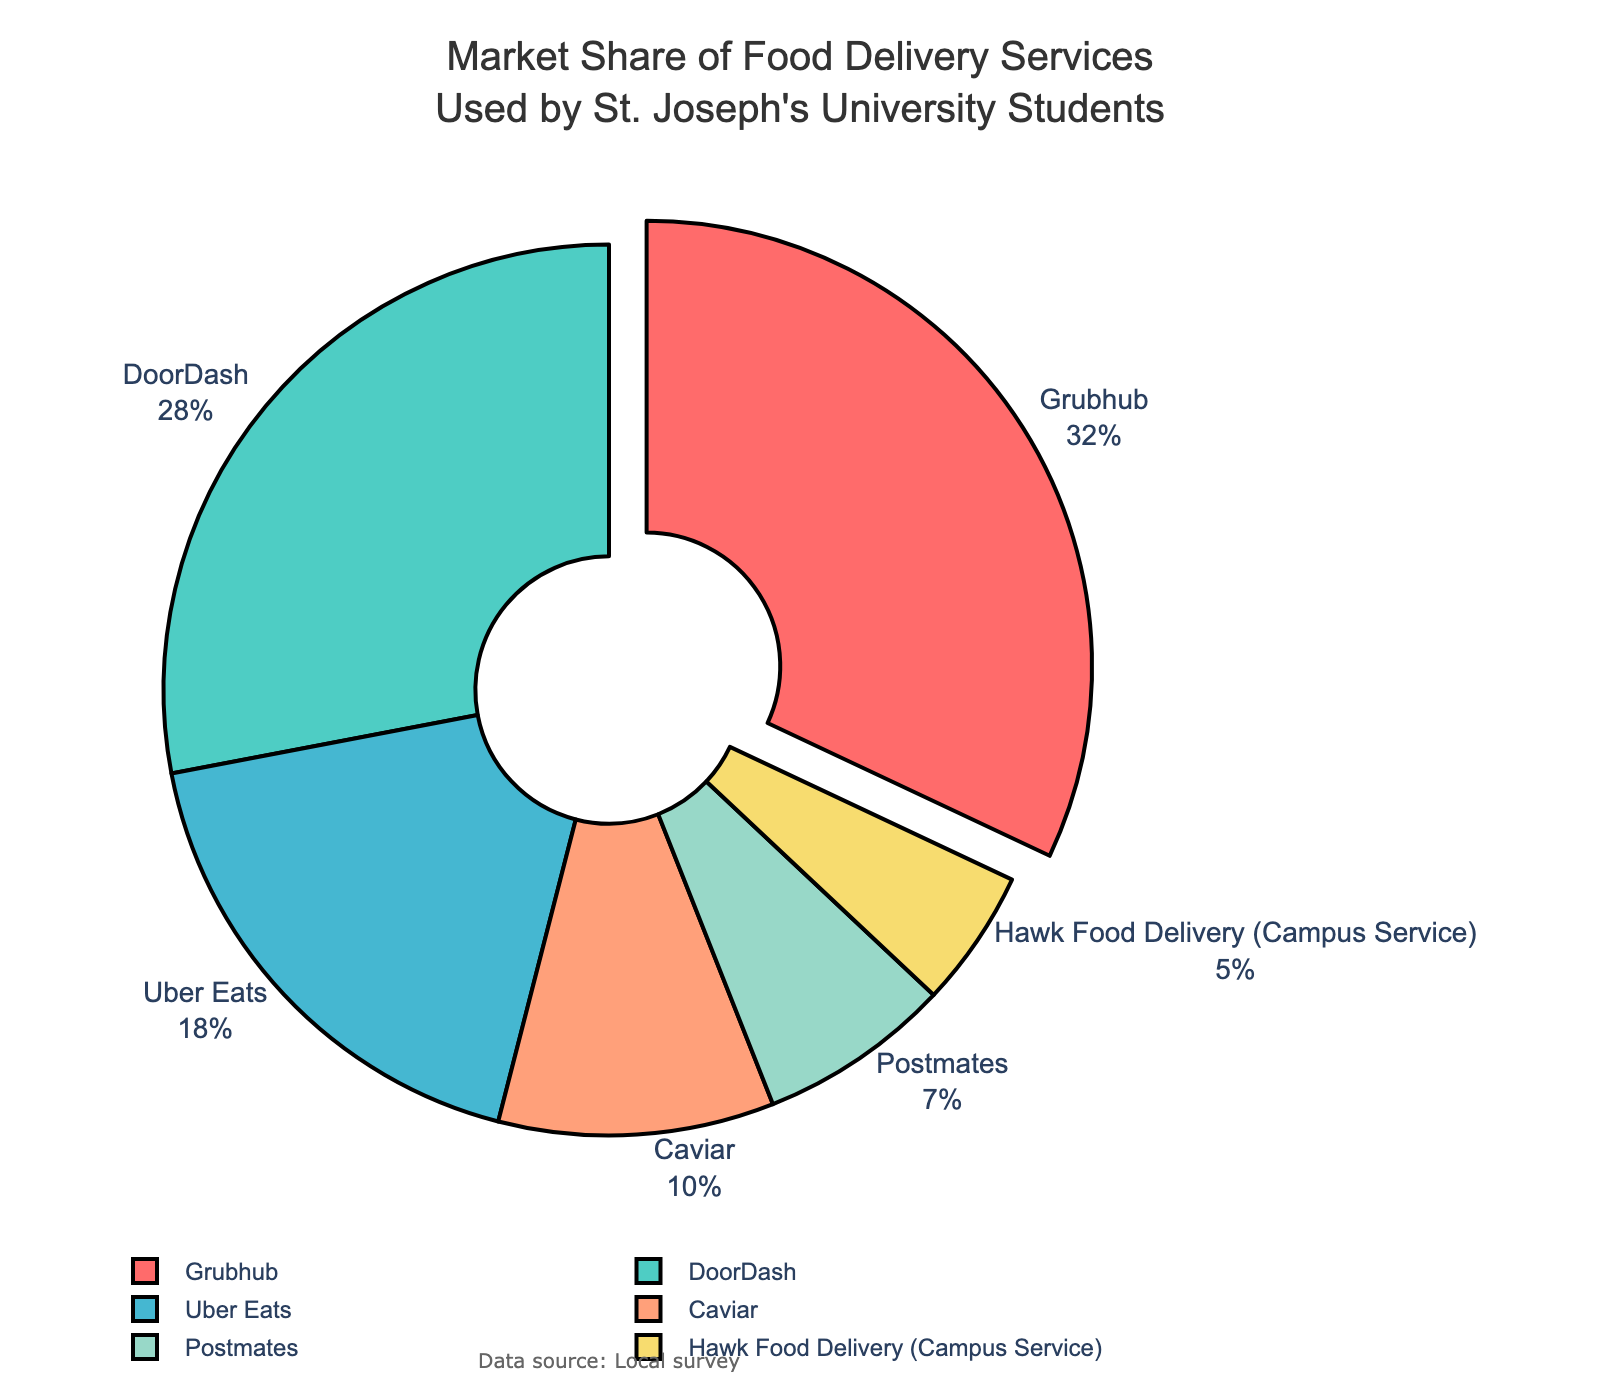What is the market share percentage of the service with the highest usage? The service with the highest usage can be found by identifying the largest segment in the pie chart, which is the one slightly pulled out, labeled Grubhub. The percentage displayed for Grubhub is 32%.
Answer: 32% What is the combined market share of Uber Eats and Caviar? To find the combined market share, look at the percentages displayed for Uber Eats and Caviar. Uber Eats has 18% and Caviar has 10%. Add these percentages to get the combined market share: 18% + 10% = 28%.
Answer: 28% Which service has the smallest market share? To find the service with the smallest market share, identify the smallest segment in the pie chart. The label of this segment is Hawk Food Delivery (Campus Service) with a 5% market share.
Answer: Hawk Food Delivery (Campus Service) Compare the market share of DoorDash and Postmates. Which one is larger and by how much? Identify the segments for DoorDash and Postmates in the pie chart. DoorDash has 28% and Postmates has 7%. Subtract the smaller percentage from the larger percentage: 28% - 7% = 21%. DoorDash has a larger market share by 21%.
Answer: DoorDash by 21% What are the colors used to represent Grubhub and Caviar? Identify the colors of the segments labeled Grubhub and Caviar from the pie chart. Grubhub is represented by red, and Caviar is represented by a peach color.
Answer: red and peach Which two services together make up over half of the market share? To find two services that together make up over 50%, look for the largest segments. Grubhub has 32% and DoorDash has 28%. Adding these two: 32% + 28% = 60%.
Answer: Grubhub and DoorDash What is the market share difference between Grubhub and Uber Eats? Identify the segments for Grubhub and Uber Eats. Grubhub has 32% and Uber Eats has 18%. Subtract the smaller percentage from the larger: 32% - 18% = 14%.
Answer: 14% Which service's segment is depicted in yellow? Identify the yellow segment in the pie chart and refer to the label of that segment. The label on the yellow segment indicates that it is for Postmates, with a 7% market share.
Answer: Postmates Add the market shares of services that have less than 10% individually. What is the total percentage? Services with less than 10% are Caviar (10%), Postmates (7%), and Hawk Food Delivery (5%). Add these percentages: 10% + 7% + 5% = 22%.
Answer: 22% Is the sum of market shares for Uber Eats and DoorDash more than Grubhub? Identify the market shares: Uber Eats is 18%, DoorDash is 28%, and Grubhub is 32%. Add the shares of Uber Eats and DoorDash: 18% + 28% = 46%. Compare this to Grubhub's 32%, and 46% is indeed more than 32%.
Answer: Yes 